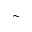<formula> <loc_0><loc_0><loc_500><loc_500>\sim</formula> 